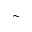<formula> <loc_0><loc_0><loc_500><loc_500>\sim</formula> 